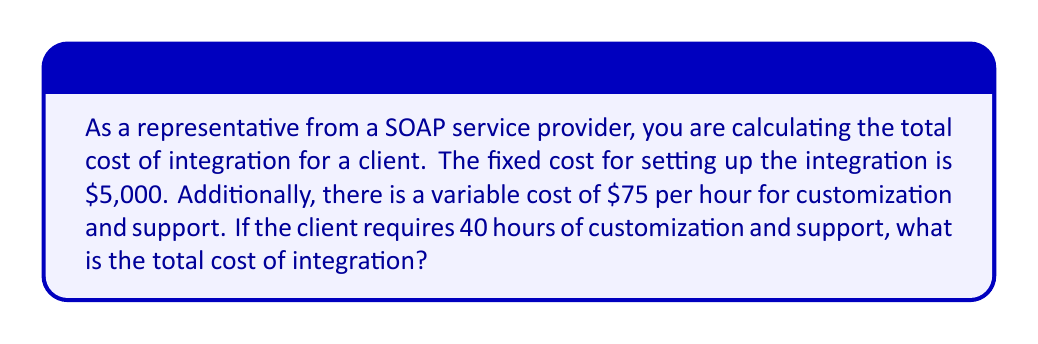What is the answer to this math problem? To solve this problem, we need to:
1. Identify the fixed cost
2. Calculate the variable cost
3. Sum the fixed and variable costs

Let's break it down step-by-step:

1. Fixed cost:
   The fixed cost is given as $5,000

2. Variable cost:
   * Cost per hour = $75
   * Number of hours = 40
   * Variable cost = $75 × 40
   $$\text{Variable cost} = 75 \times 40 = 3000$$

3. Total cost:
   * Total cost = Fixed cost + Variable cost
   $$\text{Total cost} = 5000 + 3000 = 8000$$

Therefore, the total cost of integration is $8,000.
Answer: $8,000 